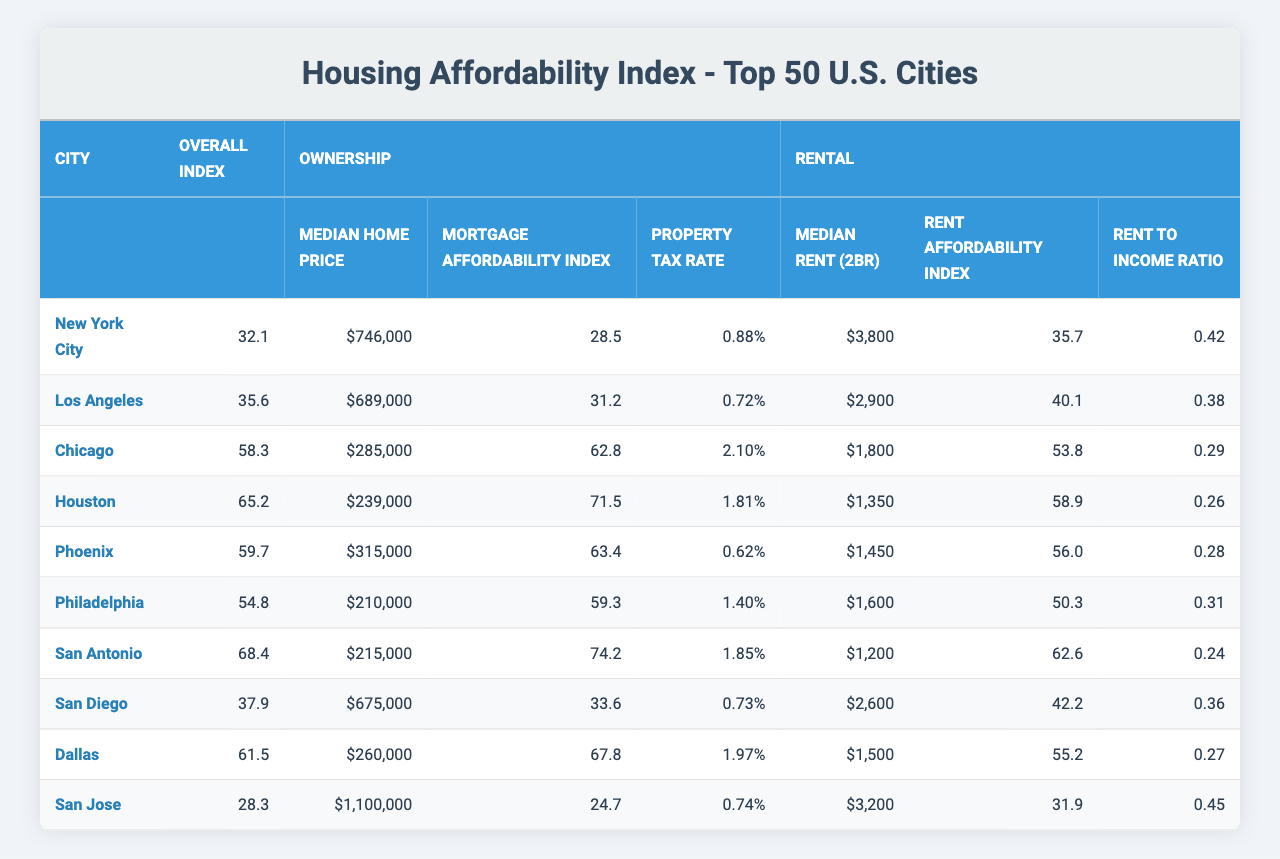What is the Median Home Price in Houston? According to the table, Houston has a Median Home Price listed as $239,000.
Answer: $239,000 Which city has the highest Rent Affordability Index? By examining the Rental section of the table, San Antonio has the highest Rent Affordability Index of 62.6.
Answer: San Antonio What is the overall affordability index for San Diego? The overall affordability index for San Diego, as indicated in the table, is 37.9.
Answer: 37.9 Calculate the average Median Rent (2BR) for New York City, Los Angeles, and San Diego. To find the average, we add their Median Rent values: (3800 + 2900 + 2600) = 9300, and divide by 3, resulting in an average of 3100.
Answer: 3100 Does Chicago have a higher Median Home Price than Philadelphia? Looking at the table, Chicago's Median Home Price is $285,000, while Philadelphia's is $210,000. Therefore, Chicago does have a higher price.
Answer: Yes What is the difference in Mortgage Affordability Index between Houston and San Jose? Houston's Mortgage Affordability Index is 71.5 and San Jose's is 24.7. The difference is 71.5 - 24.7 = 46.8.
Answer: 46.8 Which city has the lowest Overall Index, and what is that index? The table shows that San Jose has the lowest Overall Index of 28.3.
Answer: San Jose; 28.3 Is the Rent to Income Ratio in Dallas lower than in Chicago? Dallas has a Rent to Income Ratio of 0.27 and Chicago has 0.29. Therefore, Dallas's ratio is lower.
Answer: Yes What are the Median Home Prices in the cities of Phoenix and San Antonio combined? The Median Home Price for Phoenix is $315,000, and for San Antonio, it is $215,000. Adding them together gives $315,000 + $215,000 = $530,000.
Answer: $530,000 Which city shows a decrease in both Median Rent and Median Home Price when compared to New York City? Looking at Los Angeles, we see its Median Rent is $2,900 and Median Home Price is $689,000, which are both lower than those for New York City.
Answer: Los Angeles 